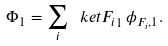<formula> <loc_0><loc_0><loc_500><loc_500>\Phi _ { 1 } = \sum _ { i } \ k e t { F _ { i } } _ { 1 } \, \phi _ { F _ { i } , 1 } .</formula> 